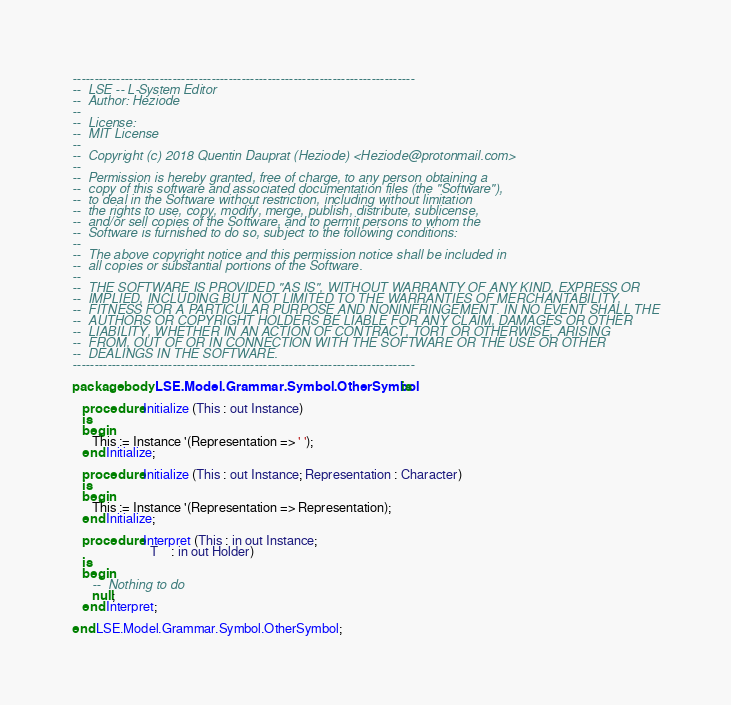<code> <loc_0><loc_0><loc_500><loc_500><_Ada_>-------------------------------------------------------------------------------
--  LSE -- L-System Editor
--  Author: Heziode
--
--  License:
--  MIT License
--
--  Copyright (c) 2018 Quentin Dauprat (Heziode) <Heziode@protonmail.com>
--
--  Permission is hereby granted, free of charge, to any person obtaining a
--  copy of this software and associated documentation files (the "Software"),
--  to deal in the Software without restriction, including without limitation
--  the rights to use, copy, modify, merge, publish, distribute, sublicense,
--  and/or sell copies of the Software, and to permit persons to whom the
--  Software is furnished to do so, subject to the following conditions:
--
--  The above copyright notice and this permission notice shall be included in
--  all copies or substantial portions of the Software.
--
--  THE SOFTWARE IS PROVIDED "AS IS", WITHOUT WARRANTY OF ANY KIND, EXPRESS OR
--  IMPLIED, INCLUDING BUT NOT LIMITED TO THE WARRANTIES OF MERCHANTABILITY,
--  FITNESS FOR A PARTICULAR PURPOSE AND NONINFRINGEMENT. IN NO EVENT SHALL THE
--  AUTHORS OR COPYRIGHT HOLDERS BE LIABLE FOR ANY CLAIM, DAMAGES OR OTHER
--  LIABILITY, WHETHER IN AN ACTION OF CONTRACT, TORT OR OTHERWISE, ARISING
--  FROM, OUT OF OR IN CONNECTION WITH THE SOFTWARE OR THE USE OR OTHER
--  DEALINGS IN THE SOFTWARE.
-------------------------------------------------------------------------------

package body LSE.Model.Grammar.Symbol.OtherSymbol is

   procedure Initialize (This : out Instance)
   is
   begin
      This := Instance '(Representation => ' ');
   end Initialize;

   procedure Initialize (This : out Instance; Representation : Character)
   is
   begin
      This := Instance '(Representation => Representation);
   end Initialize;

   procedure Interpret (This : in out Instance;
                        T    : in out Holder)
   is
   begin
      --  Nothing to do
      null;
   end Interpret;

end LSE.Model.Grammar.Symbol.OtherSymbol;
</code> 